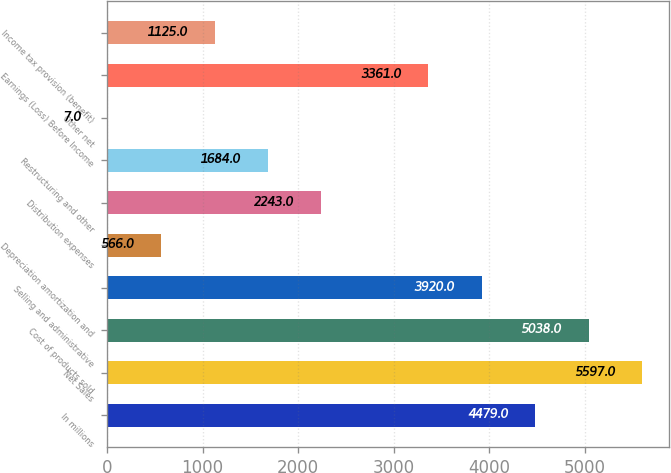Convert chart. <chart><loc_0><loc_0><loc_500><loc_500><bar_chart><fcel>In millions<fcel>Net Sales<fcel>Cost of products sold<fcel>Selling and administrative<fcel>Depreciation amortization and<fcel>Distribution expenses<fcel>Restructuring and other<fcel>Other net<fcel>Earnings (Loss) Before Income<fcel>Income tax provision (benefit)<nl><fcel>4479<fcel>5597<fcel>5038<fcel>3920<fcel>566<fcel>2243<fcel>1684<fcel>7<fcel>3361<fcel>1125<nl></chart> 